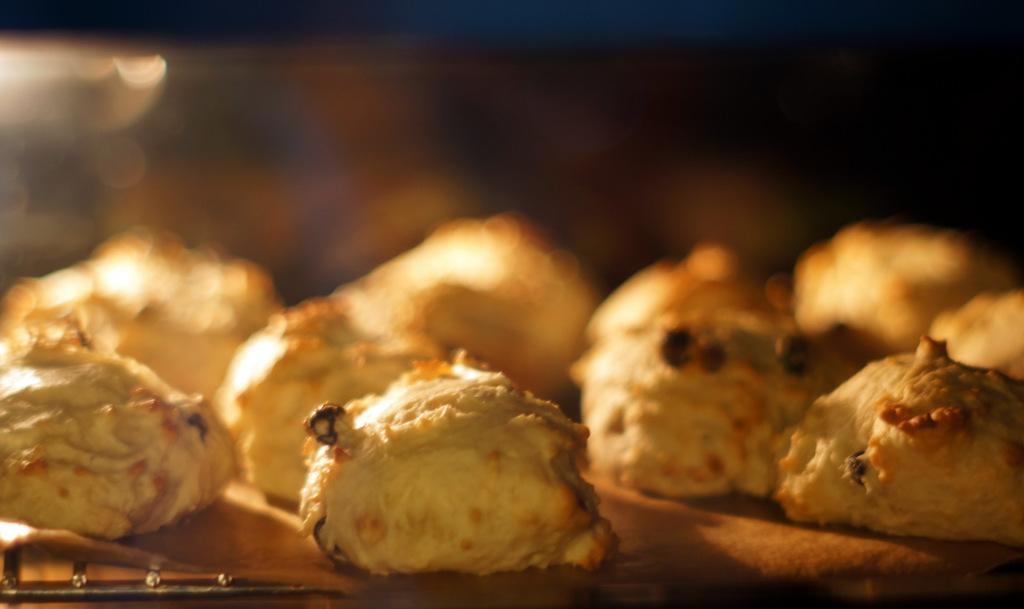What is the main focus of the image? The main focus of the image is the cookies on a tray. Can you describe the background of the image? The background of the image is blurred. How many lizards are sitting on the mailbox in the image? There are no lizards or mailbox present in the image. What type of magic is being performed with the cookies in the image? There is no magic or any indication of a magical event in the image; it simply shows cookies on a tray. 